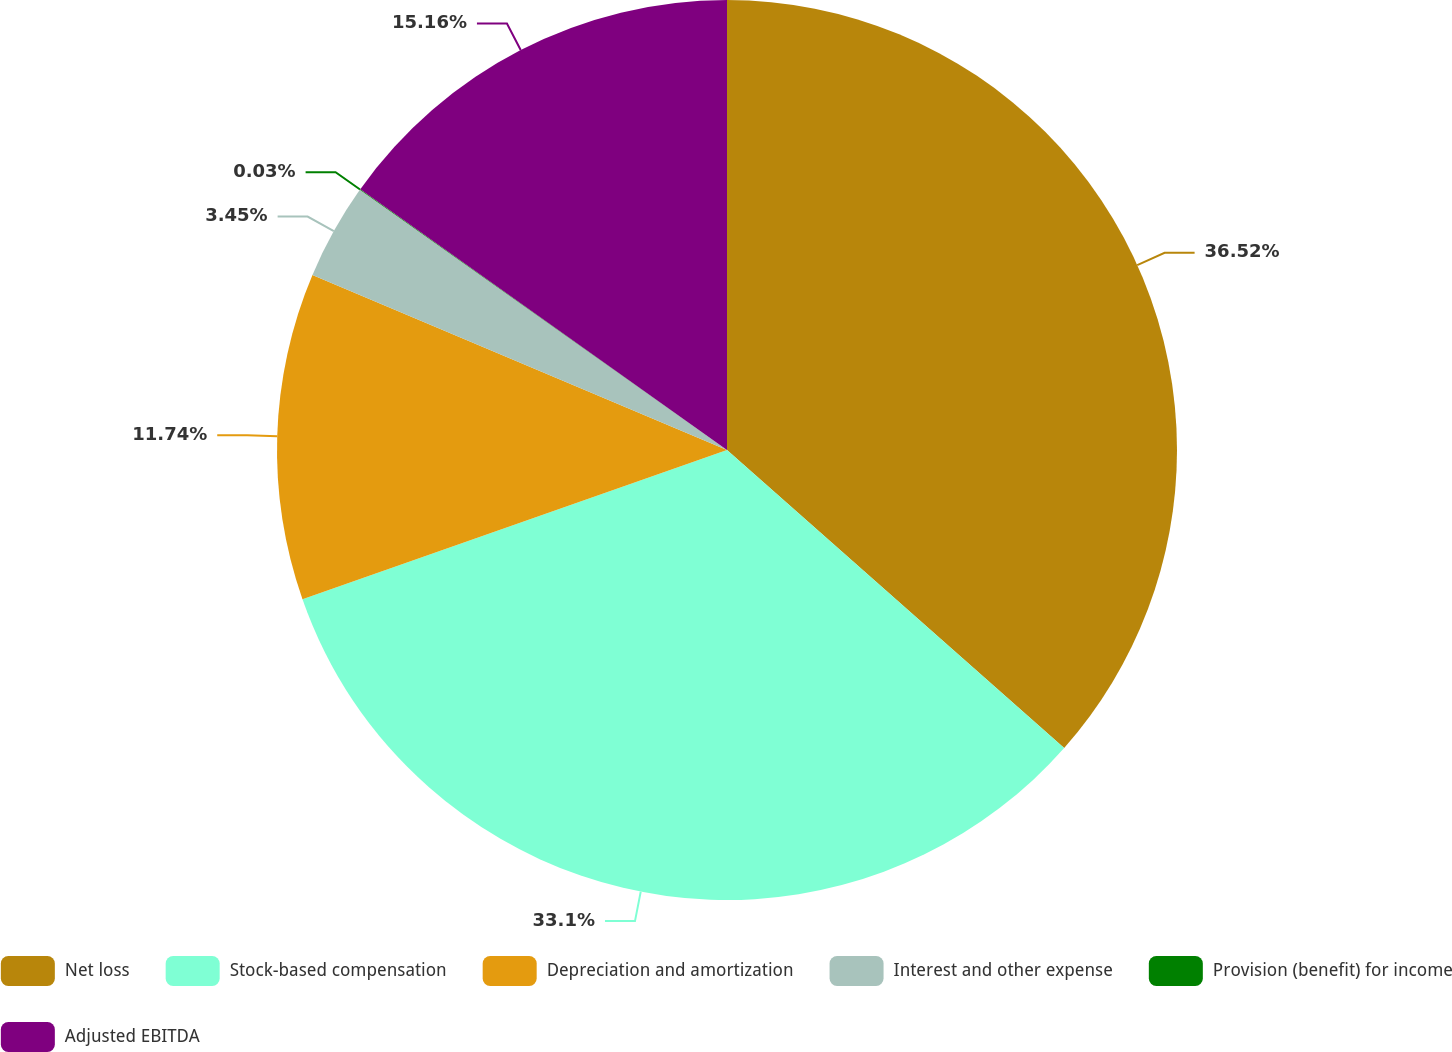<chart> <loc_0><loc_0><loc_500><loc_500><pie_chart><fcel>Net loss<fcel>Stock-based compensation<fcel>Depreciation and amortization<fcel>Interest and other expense<fcel>Provision (benefit) for income<fcel>Adjusted EBITDA<nl><fcel>36.52%<fcel>33.1%<fcel>11.74%<fcel>3.45%<fcel>0.03%<fcel>15.16%<nl></chart> 